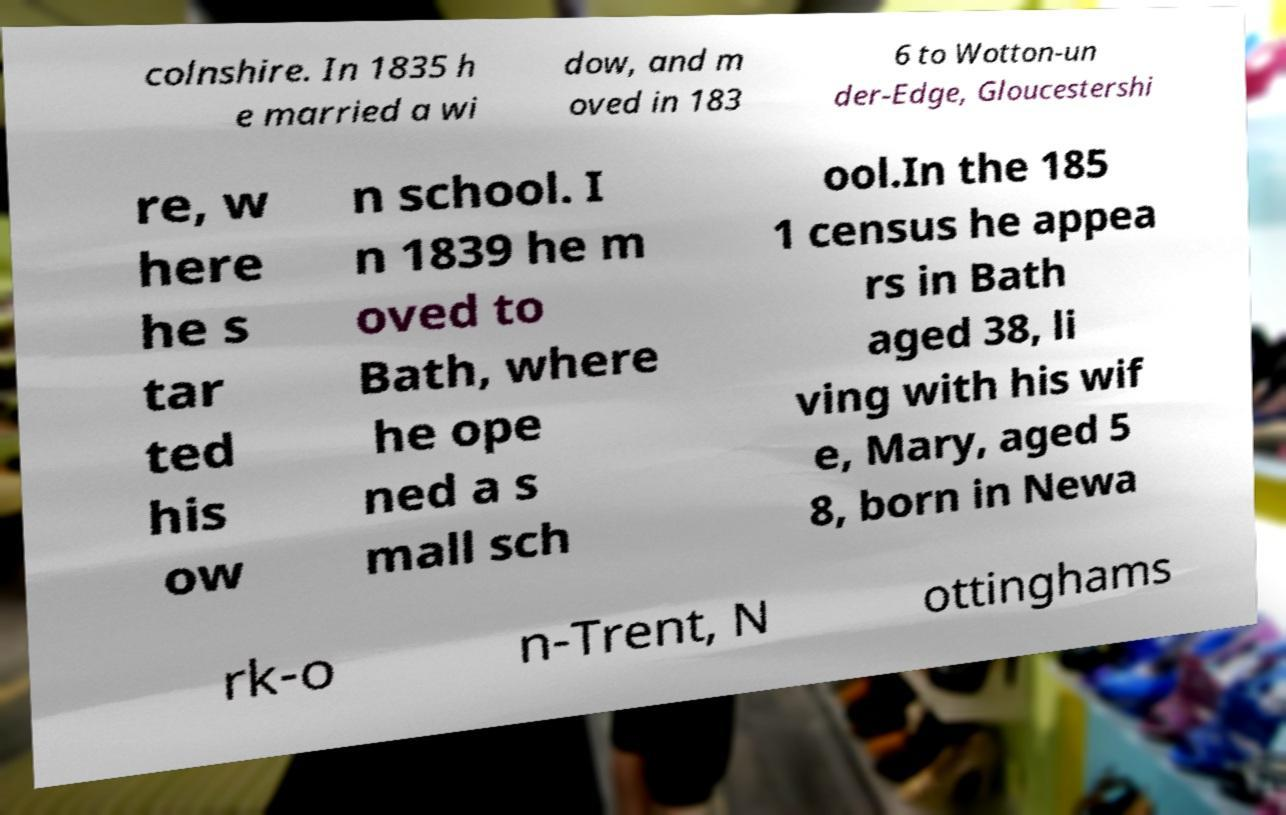For documentation purposes, I need the text within this image transcribed. Could you provide that? colnshire. In 1835 h e married a wi dow, and m oved in 183 6 to Wotton-un der-Edge, Gloucestershi re, w here he s tar ted his ow n school. I n 1839 he m oved to Bath, where he ope ned a s mall sch ool.In the 185 1 census he appea rs in Bath aged 38, li ving with his wif e, Mary, aged 5 8, born in Newa rk-o n-Trent, N ottinghams 